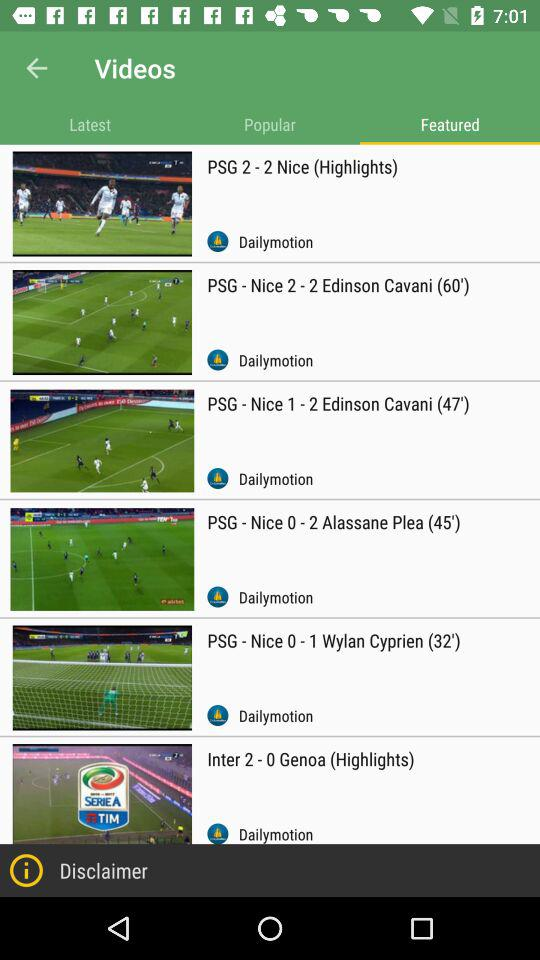What is the selected tab? The selected tab is "Featured". 